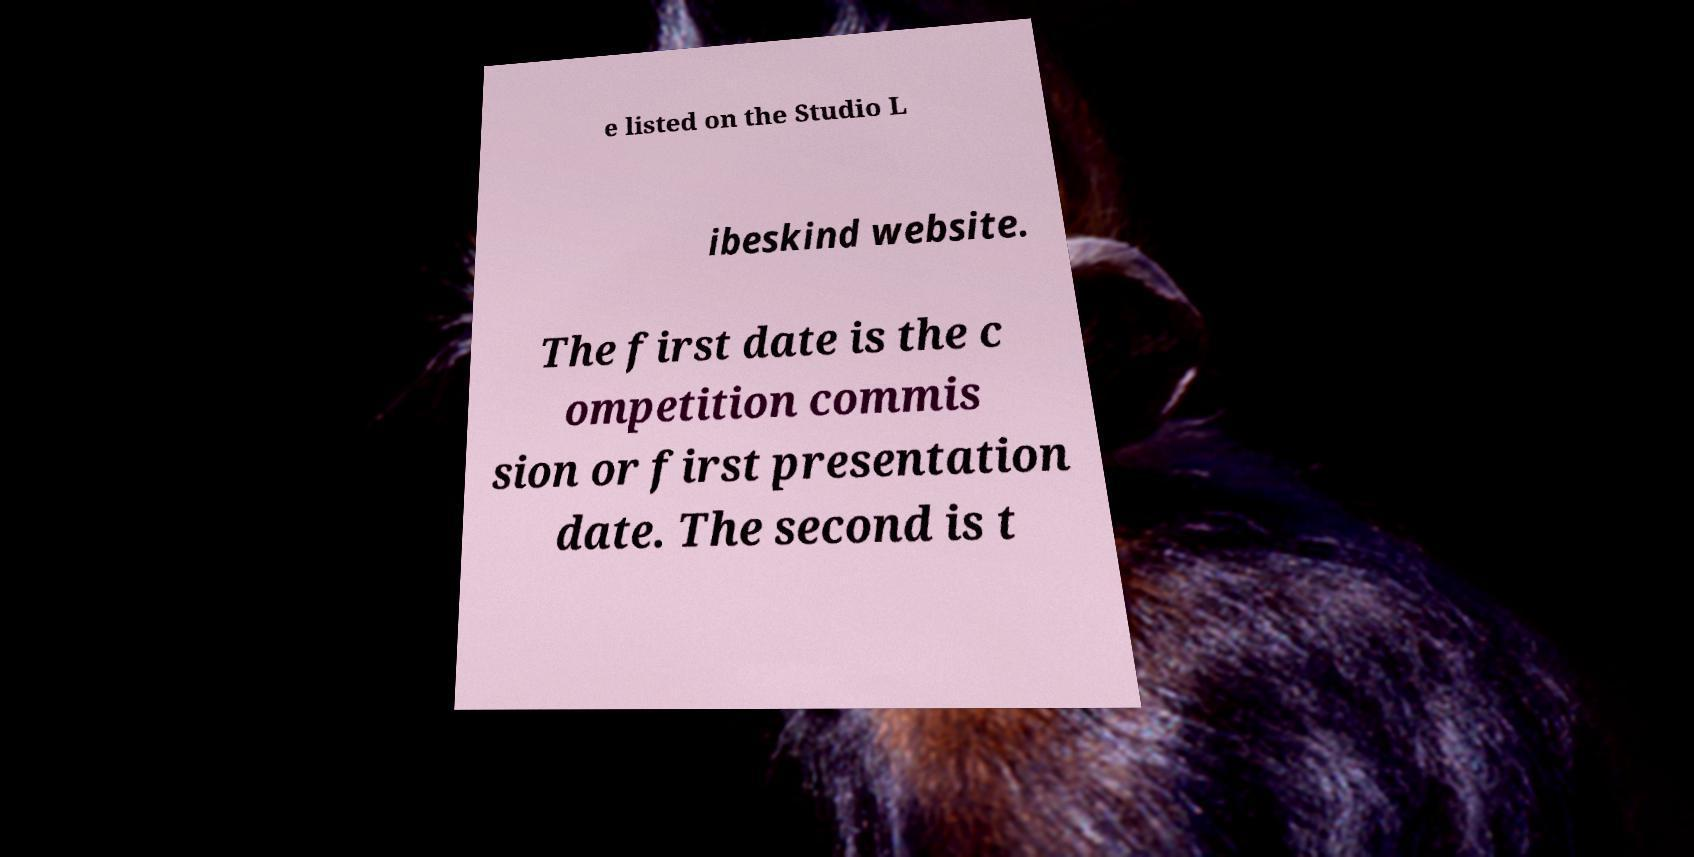Could you assist in decoding the text presented in this image and type it out clearly? e listed on the Studio L ibeskind website. The first date is the c ompetition commis sion or first presentation date. The second is t 